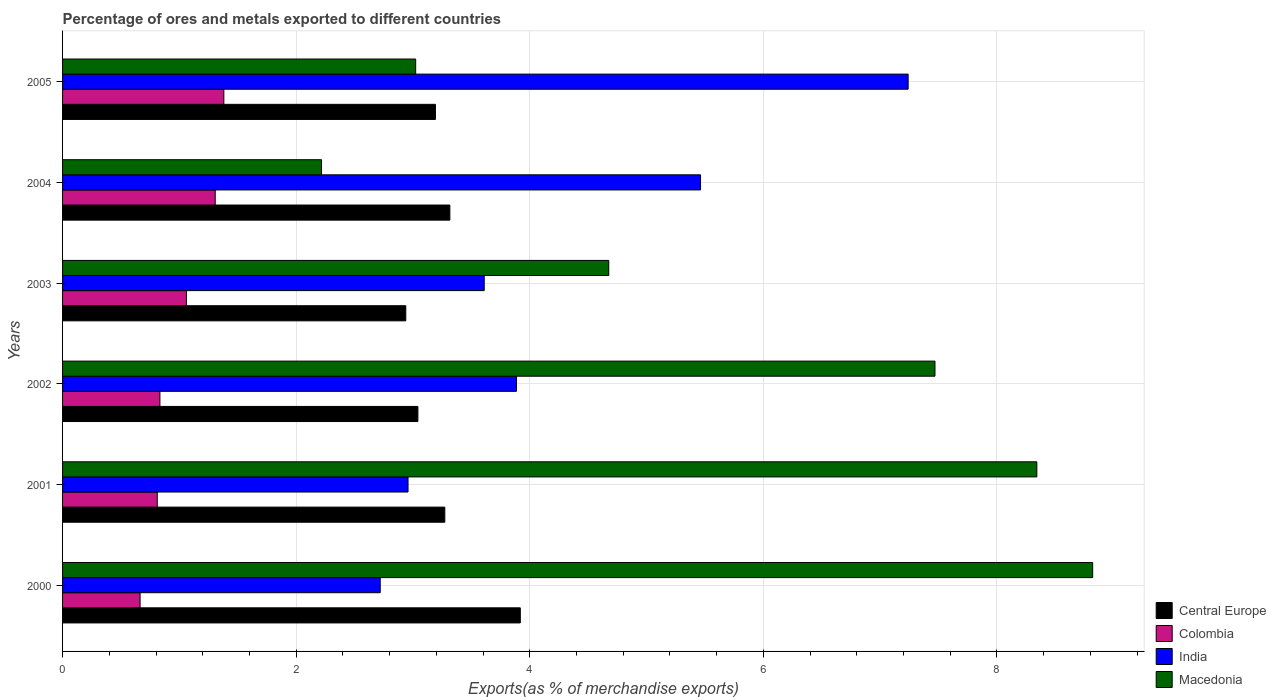How many different coloured bars are there?
Your response must be concise. 4. Are the number of bars per tick equal to the number of legend labels?
Offer a terse response. Yes. How many bars are there on the 5th tick from the top?
Ensure brevity in your answer.  4. How many bars are there on the 2nd tick from the bottom?
Your response must be concise. 4. What is the percentage of exports to different countries in Colombia in 2002?
Offer a very short reply. 0.83. Across all years, what is the maximum percentage of exports to different countries in India?
Your answer should be compact. 7.24. Across all years, what is the minimum percentage of exports to different countries in Central Europe?
Make the answer very short. 2.94. In which year was the percentage of exports to different countries in Central Europe maximum?
Your answer should be compact. 2000. What is the total percentage of exports to different countries in India in the graph?
Give a very brief answer. 25.88. What is the difference between the percentage of exports to different countries in Central Europe in 2000 and that in 2001?
Your response must be concise. 0.65. What is the difference between the percentage of exports to different countries in Colombia in 2005 and the percentage of exports to different countries in India in 2000?
Provide a succinct answer. -1.34. What is the average percentage of exports to different countries in Central Europe per year?
Your response must be concise. 3.28. In the year 2002, what is the difference between the percentage of exports to different countries in Colombia and percentage of exports to different countries in Macedonia?
Your response must be concise. -6.64. In how many years, is the percentage of exports to different countries in Colombia greater than 1.6 %?
Your answer should be very brief. 0. What is the ratio of the percentage of exports to different countries in India in 2001 to that in 2005?
Offer a very short reply. 0.41. Is the difference between the percentage of exports to different countries in Colombia in 2001 and 2003 greater than the difference between the percentage of exports to different countries in Macedonia in 2001 and 2003?
Make the answer very short. No. What is the difference between the highest and the second highest percentage of exports to different countries in Macedonia?
Keep it short and to the point. 0.48. What is the difference between the highest and the lowest percentage of exports to different countries in Colombia?
Make the answer very short. 0.72. Is the sum of the percentage of exports to different countries in Central Europe in 2003 and 2004 greater than the maximum percentage of exports to different countries in Colombia across all years?
Ensure brevity in your answer.  Yes. Is it the case that in every year, the sum of the percentage of exports to different countries in India and percentage of exports to different countries in Macedonia is greater than the sum of percentage of exports to different countries in Central Europe and percentage of exports to different countries in Colombia?
Ensure brevity in your answer.  No. What does the 1st bar from the top in 2004 represents?
Your answer should be compact. Macedonia. Is it the case that in every year, the sum of the percentage of exports to different countries in Colombia and percentage of exports to different countries in Macedonia is greater than the percentage of exports to different countries in India?
Give a very brief answer. No. How many bars are there?
Ensure brevity in your answer.  24. Are the values on the major ticks of X-axis written in scientific E-notation?
Offer a very short reply. No. Does the graph contain any zero values?
Give a very brief answer. No. How many legend labels are there?
Your answer should be compact. 4. How are the legend labels stacked?
Your answer should be compact. Vertical. What is the title of the graph?
Provide a short and direct response. Percentage of ores and metals exported to different countries. What is the label or title of the X-axis?
Provide a succinct answer. Exports(as % of merchandise exports). What is the label or title of the Y-axis?
Your answer should be compact. Years. What is the Exports(as % of merchandise exports) in Central Europe in 2000?
Your response must be concise. 3.92. What is the Exports(as % of merchandise exports) of Colombia in 2000?
Your response must be concise. 0.66. What is the Exports(as % of merchandise exports) in India in 2000?
Provide a short and direct response. 2.72. What is the Exports(as % of merchandise exports) of Macedonia in 2000?
Ensure brevity in your answer.  8.82. What is the Exports(as % of merchandise exports) in Central Europe in 2001?
Provide a short and direct response. 3.27. What is the Exports(as % of merchandise exports) in Colombia in 2001?
Offer a terse response. 0.81. What is the Exports(as % of merchandise exports) in India in 2001?
Your answer should be very brief. 2.96. What is the Exports(as % of merchandise exports) of Macedonia in 2001?
Keep it short and to the point. 8.34. What is the Exports(as % of merchandise exports) of Central Europe in 2002?
Your answer should be very brief. 3.04. What is the Exports(as % of merchandise exports) of Colombia in 2002?
Keep it short and to the point. 0.83. What is the Exports(as % of merchandise exports) in India in 2002?
Provide a succinct answer. 3.89. What is the Exports(as % of merchandise exports) of Macedonia in 2002?
Ensure brevity in your answer.  7.47. What is the Exports(as % of merchandise exports) in Central Europe in 2003?
Your answer should be compact. 2.94. What is the Exports(as % of merchandise exports) of Colombia in 2003?
Keep it short and to the point. 1.06. What is the Exports(as % of merchandise exports) of India in 2003?
Your answer should be very brief. 3.61. What is the Exports(as % of merchandise exports) in Macedonia in 2003?
Your response must be concise. 4.68. What is the Exports(as % of merchandise exports) of Central Europe in 2004?
Provide a short and direct response. 3.32. What is the Exports(as % of merchandise exports) of Colombia in 2004?
Provide a short and direct response. 1.31. What is the Exports(as % of merchandise exports) of India in 2004?
Offer a very short reply. 5.46. What is the Exports(as % of merchandise exports) in Macedonia in 2004?
Your answer should be compact. 2.22. What is the Exports(as % of merchandise exports) in Central Europe in 2005?
Give a very brief answer. 3.19. What is the Exports(as % of merchandise exports) in Colombia in 2005?
Provide a succinct answer. 1.38. What is the Exports(as % of merchandise exports) of India in 2005?
Make the answer very short. 7.24. What is the Exports(as % of merchandise exports) of Macedonia in 2005?
Keep it short and to the point. 3.02. Across all years, what is the maximum Exports(as % of merchandise exports) in Central Europe?
Offer a very short reply. 3.92. Across all years, what is the maximum Exports(as % of merchandise exports) in Colombia?
Offer a very short reply. 1.38. Across all years, what is the maximum Exports(as % of merchandise exports) of India?
Provide a succinct answer. 7.24. Across all years, what is the maximum Exports(as % of merchandise exports) in Macedonia?
Provide a short and direct response. 8.82. Across all years, what is the minimum Exports(as % of merchandise exports) of Central Europe?
Your answer should be compact. 2.94. Across all years, what is the minimum Exports(as % of merchandise exports) in Colombia?
Give a very brief answer. 0.66. Across all years, what is the minimum Exports(as % of merchandise exports) of India?
Offer a very short reply. 2.72. Across all years, what is the minimum Exports(as % of merchandise exports) in Macedonia?
Offer a very short reply. 2.22. What is the total Exports(as % of merchandise exports) of Central Europe in the graph?
Your response must be concise. 19.68. What is the total Exports(as % of merchandise exports) in Colombia in the graph?
Your response must be concise. 6.06. What is the total Exports(as % of merchandise exports) in India in the graph?
Provide a short and direct response. 25.88. What is the total Exports(as % of merchandise exports) in Macedonia in the graph?
Ensure brevity in your answer.  34.55. What is the difference between the Exports(as % of merchandise exports) of Central Europe in 2000 and that in 2001?
Keep it short and to the point. 0.65. What is the difference between the Exports(as % of merchandise exports) of Colombia in 2000 and that in 2001?
Ensure brevity in your answer.  -0.15. What is the difference between the Exports(as % of merchandise exports) of India in 2000 and that in 2001?
Provide a short and direct response. -0.24. What is the difference between the Exports(as % of merchandise exports) of Macedonia in 2000 and that in 2001?
Ensure brevity in your answer.  0.48. What is the difference between the Exports(as % of merchandise exports) of Central Europe in 2000 and that in 2002?
Provide a short and direct response. 0.88. What is the difference between the Exports(as % of merchandise exports) in Colombia in 2000 and that in 2002?
Offer a terse response. -0.17. What is the difference between the Exports(as % of merchandise exports) in India in 2000 and that in 2002?
Ensure brevity in your answer.  -1.17. What is the difference between the Exports(as % of merchandise exports) of Macedonia in 2000 and that in 2002?
Keep it short and to the point. 1.35. What is the difference between the Exports(as % of merchandise exports) of Central Europe in 2000 and that in 2003?
Make the answer very short. 0.98. What is the difference between the Exports(as % of merchandise exports) in Colombia in 2000 and that in 2003?
Provide a short and direct response. -0.4. What is the difference between the Exports(as % of merchandise exports) in India in 2000 and that in 2003?
Your answer should be very brief. -0.89. What is the difference between the Exports(as % of merchandise exports) of Macedonia in 2000 and that in 2003?
Offer a terse response. 4.14. What is the difference between the Exports(as % of merchandise exports) of Central Europe in 2000 and that in 2004?
Your response must be concise. 0.6. What is the difference between the Exports(as % of merchandise exports) of Colombia in 2000 and that in 2004?
Make the answer very short. -0.64. What is the difference between the Exports(as % of merchandise exports) of India in 2000 and that in 2004?
Keep it short and to the point. -2.74. What is the difference between the Exports(as % of merchandise exports) in Macedonia in 2000 and that in 2004?
Provide a short and direct response. 6.6. What is the difference between the Exports(as % of merchandise exports) of Central Europe in 2000 and that in 2005?
Offer a terse response. 0.73. What is the difference between the Exports(as % of merchandise exports) of Colombia in 2000 and that in 2005?
Give a very brief answer. -0.72. What is the difference between the Exports(as % of merchandise exports) in India in 2000 and that in 2005?
Make the answer very short. -4.52. What is the difference between the Exports(as % of merchandise exports) in Macedonia in 2000 and that in 2005?
Ensure brevity in your answer.  5.8. What is the difference between the Exports(as % of merchandise exports) of Central Europe in 2001 and that in 2002?
Your response must be concise. 0.23. What is the difference between the Exports(as % of merchandise exports) of Colombia in 2001 and that in 2002?
Offer a very short reply. -0.02. What is the difference between the Exports(as % of merchandise exports) of India in 2001 and that in 2002?
Give a very brief answer. -0.93. What is the difference between the Exports(as % of merchandise exports) in Macedonia in 2001 and that in 2002?
Ensure brevity in your answer.  0.87. What is the difference between the Exports(as % of merchandise exports) in Central Europe in 2001 and that in 2003?
Your response must be concise. 0.33. What is the difference between the Exports(as % of merchandise exports) in Colombia in 2001 and that in 2003?
Keep it short and to the point. -0.25. What is the difference between the Exports(as % of merchandise exports) of India in 2001 and that in 2003?
Your response must be concise. -0.65. What is the difference between the Exports(as % of merchandise exports) in Macedonia in 2001 and that in 2003?
Provide a short and direct response. 3.67. What is the difference between the Exports(as % of merchandise exports) of Central Europe in 2001 and that in 2004?
Your answer should be compact. -0.04. What is the difference between the Exports(as % of merchandise exports) of Colombia in 2001 and that in 2004?
Offer a terse response. -0.5. What is the difference between the Exports(as % of merchandise exports) of India in 2001 and that in 2004?
Offer a very short reply. -2.5. What is the difference between the Exports(as % of merchandise exports) in Macedonia in 2001 and that in 2004?
Your answer should be very brief. 6.12. What is the difference between the Exports(as % of merchandise exports) of Central Europe in 2001 and that in 2005?
Give a very brief answer. 0.08. What is the difference between the Exports(as % of merchandise exports) in Colombia in 2001 and that in 2005?
Offer a terse response. -0.57. What is the difference between the Exports(as % of merchandise exports) of India in 2001 and that in 2005?
Give a very brief answer. -4.28. What is the difference between the Exports(as % of merchandise exports) in Macedonia in 2001 and that in 2005?
Provide a short and direct response. 5.32. What is the difference between the Exports(as % of merchandise exports) of Central Europe in 2002 and that in 2003?
Offer a very short reply. 0.1. What is the difference between the Exports(as % of merchandise exports) in Colombia in 2002 and that in 2003?
Give a very brief answer. -0.23. What is the difference between the Exports(as % of merchandise exports) of India in 2002 and that in 2003?
Your response must be concise. 0.28. What is the difference between the Exports(as % of merchandise exports) of Macedonia in 2002 and that in 2003?
Your response must be concise. 2.79. What is the difference between the Exports(as % of merchandise exports) in Central Europe in 2002 and that in 2004?
Your answer should be compact. -0.27. What is the difference between the Exports(as % of merchandise exports) in Colombia in 2002 and that in 2004?
Your answer should be very brief. -0.47. What is the difference between the Exports(as % of merchandise exports) in India in 2002 and that in 2004?
Your answer should be very brief. -1.58. What is the difference between the Exports(as % of merchandise exports) in Macedonia in 2002 and that in 2004?
Your answer should be very brief. 5.25. What is the difference between the Exports(as % of merchandise exports) in Central Europe in 2002 and that in 2005?
Offer a very short reply. -0.15. What is the difference between the Exports(as % of merchandise exports) in Colombia in 2002 and that in 2005?
Your answer should be very brief. -0.55. What is the difference between the Exports(as % of merchandise exports) in India in 2002 and that in 2005?
Your response must be concise. -3.35. What is the difference between the Exports(as % of merchandise exports) of Macedonia in 2002 and that in 2005?
Keep it short and to the point. 4.45. What is the difference between the Exports(as % of merchandise exports) in Central Europe in 2003 and that in 2004?
Give a very brief answer. -0.38. What is the difference between the Exports(as % of merchandise exports) of Colombia in 2003 and that in 2004?
Provide a short and direct response. -0.25. What is the difference between the Exports(as % of merchandise exports) of India in 2003 and that in 2004?
Give a very brief answer. -1.85. What is the difference between the Exports(as % of merchandise exports) in Macedonia in 2003 and that in 2004?
Offer a very short reply. 2.46. What is the difference between the Exports(as % of merchandise exports) of Central Europe in 2003 and that in 2005?
Your response must be concise. -0.25. What is the difference between the Exports(as % of merchandise exports) in Colombia in 2003 and that in 2005?
Make the answer very short. -0.32. What is the difference between the Exports(as % of merchandise exports) in India in 2003 and that in 2005?
Provide a succinct answer. -3.63. What is the difference between the Exports(as % of merchandise exports) in Macedonia in 2003 and that in 2005?
Your answer should be compact. 1.65. What is the difference between the Exports(as % of merchandise exports) of Central Europe in 2004 and that in 2005?
Ensure brevity in your answer.  0.12. What is the difference between the Exports(as % of merchandise exports) of Colombia in 2004 and that in 2005?
Your answer should be very brief. -0.07. What is the difference between the Exports(as % of merchandise exports) in India in 2004 and that in 2005?
Offer a terse response. -1.78. What is the difference between the Exports(as % of merchandise exports) in Macedonia in 2004 and that in 2005?
Give a very brief answer. -0.81. What is the difference between the Exports(as % of merchandise exports) in Central Europe in 2000 and the Exports(as % of merchandise exports) in Colombia in 2001?
Provide a short and direct response. 3.11. What is the difference between the Exports(as % of merchandise exports) in Central Europe in 2000 and the Exports(as % of merchandise exports) in India in 2001?
Keep it short and to the point. 0.96. What is the difference between the Exports(as % of merchandise exports) of Central Europe in 2000 and the Exports(as % of merchandise exports) of Macedonia in 2001?
Provide a short and direct response. -4.42. What is the difference between the Exports(as % of merchandise exports) in Colombia in 2000 and the Exports(as % of merchandise exports) in India in 2001?
Keep it short and to the point. -2.29. What is the difference between the Exports(as % of merchandise exports) of Colombia in 2000 and the Exports(as % of merchandise exports) of Macedonia in 2001?
Ensure brevity in your answer.  -7.68. What is the difference between the Exports(as % of merchandise exports) of India in 2000 and the Exports(as % of merchandise exports) of Macedonia in 2001?
Keep it short and to the point. -5.62. What is the difference between the Exports(as % of merchandise exports) in Central Europe in 2000 and the Exports(as % of merchandise exports) in Colombia in 2002?
Your answer should be compact. 3.09. What is the difference between the Exports(as % of merchandise exports) in Central Europe in 2000 and the Exports(as % of merchandise exports) in India in 2002?
Your answer should be compact. 0.03. What is the difference between the Exports(as % of merchandise exports) of Central Europe in 2000 and the Exports(as % of merchandise exports) of Macedonia in 2002?
Ensure brevity in your answer.  -3.55. What is the difference between the Exports(as % of merchandise exports) in Colombia in 2000 and the Exports(as % of merchandise exports) in India in 2002?
Give a very brief answer. -3.22. What is the difference between the Exports(as % of merchandise exports) in Colombia in 2000 and the Exports(as % of merchandise exports) in Macedonia in 2002?
Make the answer very short. -6.81. What is the difference between the Exports(as % of merchandise exports) in India in 2000 and the Exports(as % of merchandise exports) in Macedonia in 2002?
Offer a very short reply. -4.75. What is the difference between the Exports(as % of merchandise exports) of Central Europe in 2000 and the Exports(as % of merchandise exports) of Colombia in 2003?
Offer a terse response. 2.86. What is the difference between the Exports(as % of merchandise exports) in Central Europe in 2000 and the Exports(as % of merchandise exports) in India in 2003?
Your answer should be very brief. 0.31. What is the difference between the Exports(as % of merchandise exports) in Central Europe in 2000 and the Exports(as % of merchandise exports) in Macedonia in 2003?
Ensure brevity in your answer.  -0.76. What is the difference between the Exports(as % of merchandise exports) in Colombia in 2000 and the Exports(as % of merchandise exports) in India in 2003?
Keep it short and to the point. -2.95. What is the difference between the Exports(as % of merchandise exports) of Colombia in 2000 and the Exports(as % of merchandise exports) of Macedonia in 2003?
Give a very brief answer. -4.01. What is the difference between the Exports(as % of merchandise exports) of India in 2000 and the Exports(as % of merchandise exports) of Macedonia in 2003?
Provide a short and direct response. -1.96. What is the difference between the Exports(as % of merchandise exports) in Central Europe in 2000 and the Exports(as % of merchandise exports) in Colombia in 2004?
Keep it short and to the point. 2.61. What is the difference between the Exports(as % of merchandise exports) in Central Europe in 2000 and the Exports(as % of merchandise exports) in India in 2004?
Your answer should be very brief. -1.54. What is the difference between the Exports(as % of merchandise exports) in Central Europe in 2000 and the Exports(as % of merchandise exports) in Macedonia in 2004?
Provide a short and direct response. 1.7. What is the difference between the Exports(as % of merchandise exports) of Colombia in 2000 and the Exports(as % of merchandise exports) of India in 2004?
Offer a terse response. -4.8. What is the difference between the Exports(as % of merchandise exports) in Colombia in 2000 and the Exports(as % of merchandise exports) in Macedonia in 2004?
Offer a very short reply. -1.55. What is the difference between the Exports(as % of merchandise exports) in India in 2000 and the Exports(as % of merchandise exports) in Macedonia in 2004?
Provide a succinct answer. 0.5. What is the difference between the Exports(as % of merchandise exports) in Central Europe in 2000 and the Exports(as % of merchandise exports) in Colombia in 2005?
Offer a terse response. 2.54. What is the difference between the Exports(as % of merchandise exports) in Central Europe in 2000 and the Exports(as % of merchandise exports) in India in 2005?
Offer a very short reply. -3.32. What is the difference between the Exports(as % of merchandise exports) of Central Europe in 2000 and the Exports(as % of merchandise exports) of Macedonia in 2005?
Offer a terse response. 0.9. What is the difference between the Exports(as % of merchandise exports) of Colombia in 2000 and the Exports(as % of merchandise exports) of India in 2005?
Provide a succinct answer. -6.58. What is the difference between the Exports(as % of merchandise exports) in Colombia in 2000 and the Exports(as % of merchandise exports) in Macedonia in 2005?
Make the answer very short. -2.36. What is the difference between the Exports(as % of merchandise exports) in India in 2000 and the Exports(as % of merchandise exports) in Macedonia in 2005?
Your answer should be very brief. -0.3. What is the difference between the Exports(as % of merchandise exports) of Central Europe in 2001 and the Exports(as % of merchandise exports) of Colombia in 2002?
Your answer should be very brief. 2.44. What is the difference between the Exports(as % of merchandise exports) of Central Europe in 2001 and the Exports(as % of merchandise exports) of India in 2002?
Offer a very short reply. -0.61. What is the difference between the Exports(as % of merchandise exports) in Central Europe in 2001 and the Exports(as % of merchandise exports) in Macedonia in 2002?
Provide a succinct answer. -4.2. What is the difference between the Exports(as % of merchandise exports) of Colombia in 2001 and the Exports(as % of merchandise exports) of India in 2002?
Offer a very short reply. -3.08. What is the difference between the Exports(as % of merchandise exports) of Colombia in 2001 and the Exports(as % of merchandise exports) of Macedonia in 2002?
Offer a very short reply. -6.66. What is the difference between the Exports(as % of merchandise exports) of India in 2001 and the Exports(as % of merchandise exports) of Macedonia in 2002?
Provide a short and direct response. -4.51. What is the difference between the Exports(as % of merchandise exports) of Central Europe in 2001 and the Exports(as % of merchandise exports) of Colombia in 2003?
Keep it short and to the point. 2.21. What is the difference between the Exports(as % of merchandise exports) of Central Europe in 2001 and the Exports(as % of merchandise exports) of India in 2003?
Offer a very short reply. -0.34. What is the difference between the Exports(as % of merchandise exports) in Central Europe in 2001 and the Exports(as % of merchandise exports) in Macedonia in 2003?
Ensure brevity in your answer.  -1.4. What is the difference between the Exports(as % of merchandise exports) in Colombia in 2001 and the Exports(as % of merchandise exports) in India in 2003?
Your answer should be compact. -2.8. What is the difference between the Exports(as % of merchandise exports) in Colombia in 2001 and the Exports(as % of merchandise exports) in Macedonia in 2003?
Ensure brevity in your answer.  -3.87. What is the difference between the Exports(as % of merchandise exports) of India in 2001 and the Exports(as % of merchandise exports) of Macedonia in 2003?
Your answer should be compact. -1.72. What is the difference between the Exports(as % of merchandise exports) of Central Europe in 2001 and the Exports(as % of merchandise exports) of Colombia in 2004?
Offer a terse response. 1.97. What is the difference between the Exports(as % of merchandise exports) in Central Europe in 2001 and the Exports(as % of merchandise exports) in India in 2004?
Your answer should be very brief. -2.19. What is the difference between the Exports(as % of merchandise exports) of Central Europe in 2001 and the Exports(as % of merchandise exports) of Macedonia in 2004?
Give a very brief answer. 1.06. What is the difference between the Exports(as % of merchandise exports) of Colombia in 2001 and the Exports(as % of merchandise exports) of India in 2004?
Offer a terse response. -4.65. What is the difference between the Exports(as % of merchandise exports) of Colombia in 2001 and the Exports(as % of merchandise exports) of Macedonia in 2004?
Keep it short and to the point. -1.41. What is the difference between the Exports(as % of merchandise exports) of India in 2001 and the Exports(as % of merchandise exports) of Macedonia in 2004?
Your answer should be compact. 0.74. What is the difference between the Exports(as % of merchandise exports) of Central Europe in 2001 and the Exports(as % of merchandise exports) of Colombia in 2005?
Keep it short and to the point. 1.89. What is the difference between the Exports(as % of merchandise exports) in Central Europe in 2001 and the Exports(as % of merchandise exports) in India in 2005?
Keep it short and to the point. -3.97. What is the difference between the Exports(as % of merchandise exports) of Central Europe in 2001 and the Exports(as % of merchandise exports) of Macedonia in 2005?
Give a very brief answer. 0.25. What is the difference between the Exports(as % of merchandise exports) of Colombia in 2001 and the Exports(as % of merchandise exports) of India in 2005?
Your answer should be compact. -6.43. What is the difference between the Exports(as % of merchandise exports) of Colombia in 2001 and the Exports(as % of merchandise exports) of Macedonia in 2005?
Give a very brief answer. -2.21. What is the difference between the Exports(as % of merchandise exports) of India in 2001 and the Exports(as % of merchandise exports) of Macedonia in 2005?
Your response must be concise. -0.07. What is the difference between the Exports(as % of merchandise exports) in Central Europe in 2002 and the Exports(as % of merchandise exports) in Colombia in 2003?
Your response must be concise. 1.98. What is the difference between the Exports(as % of merchandise exports) in Central Europe in 2002 and the Exports(as % of merchandise exports) in India in 2003?
Provide a short and direct response. -0.57. What is the difference between the Exports(as % of merchandise exports) in Central Europe in 2002 and the Exports(as % of merchandise exports) in Macedonia in 2003?
Your answer should be very brief. -1.63. What is the difference between the Exports(as % of merchandise exports) of Colombia in 2002 and the Exports(as % of merchandise exports) of India in 2003?
Offer a very short reply. -2.78. What is the difference between the Exports(as % of merchandise exports) in Colombia in 2002 and the Exports(as % of merchandise exports) in Macedonia in 2003?
Make the answer very short. -3.84. What is the difference between the Exports(as % of merchandise exports) in India in 2002 and the Exports(as % of merchandise exports) in Macedonia in 2003?
Your answer should be compact. -0.79. What is the difference between the Exports(as % of merchandise exports) of Central Europe in 2002 and the Exports(as % of merchandise exports) of Colombia in 2004?
Your answer should be very brief. 1.74. What is the difference between the Exports(as % of merchandise exports) in Central Europe in 2002 and the Exports(as % of merchandise exports) in India in 2004?
Your answer should be compact. -2.42. What is the difference between the Exports(as % of merchandise exports) in Central Europe in 2002 and the Exports(as % of merchandise exports) in Macedonia in 2004?
Keep it short and to the point. 0.83. What is the difference between the Exports(as % of merchandise exports) in Colombia in 2002 and the Exports(as % of merchandise exports) in India in 2004?
Provide a succinct answer. -4.63. What is the difference between the Exports(as % of merchandise exports) of Colombia in 2002 and the Exports(as % of merchandise exports) of Macedonia in 2004?
Make the answer very short. -1.38. What is the difference between the Exports(as % of merchandise exports) of India in 2002 and the Exports(as % of merchandise exports) of Macedonia in 2004?
Make the answer very short. 1.67. What is the difference between the Exports(as % of merchandise exports) in Central Europe in 2002 and the Exports(as % of merchandise exports) in Colombia in 2005?
Your answer should be very brief. 1.66. What is the difference between the Exports(as % of merchandise exports) in Central Europe in 2002 and the Exports(as % of merchandise exports) in India in 2005?
Keep it short and to the point. -4.2. What is the difference between the Exports(as % of merchandise exports) in Central Europe in 2002 and the Exports(as % of merchandise exports) in Macedonia in 2005?
Your response must be concise. 0.02. What is the difference between the Exports(as % of merchandise exports) in Colombia in 2002 and the Exports(as % of merchandise exports) in India in 2005?
Ensure brevity in your answer.  -6.41. What is the difference between the Exports(as % of merchandise exports) in Colombia in 2002 and the Exports(as % of merchandise exports) in Macedonia in 2005?
Your response must be concise. -2.19. What is the difference between the Exports(as % of merchandise exports) of India in 2002 and the Exports(as % of merchandise exports) of Macedonia in 2005?
Make the answer very short. 0.86. What is the difference between the Exports(as % of merchandise exports) of Central Europe in 2003 and the Exports(as % of merchandise exports) of Colombia in 2004?
Offer a terse response. 1.63. What is the difference between the Exports(as % of merchandise exports) of Central Europe in 2003 and the Exports(as % of merchandise exports) of India in 2004?
Give a very brief answer. -2.52. What is the difference between the Exports(as % of merchandise exports) of Central Europe in 2003 and the Exports(as % of merchandise exports) of Macedonia in 2004?
Your answer should be compact. 0.72. What is the difference between the Exports(as % of merchandise exports) of Colombia in 2003 and the Exports(as % of merchandise exports) of India in 2004?
Your response must be concise. -4.4. What is the difference between the Exports(as % of merchandise exports) in Colombia in 2003 and the Exports(as % of merchandise exports) in Macedonia in 2004?
Provide a short and direct response. -1.16. What is the difference between the Exports(as % of merchandise exports) in India in 2003 and the Exports(as % of merchandise exports) in Macedonia in 2004?
Provide a succinct answer. 1.39. What is the difference between the Exports(as % of merchandise exports) in Central Europe in 2003 and the Exports(as % of merchandise exports) in Colombia in 2005?
Your response must be concise. 1.56. What is the difference between the Exports(as % of merchandise exports) of Central Europe in 2003 and the Exports(as % of merchandise exports) of India in 2005?
Ensure brevity in your answer.  -4.3. What is the difference between the Exports(as % of merchandise exports) in Central Europe in 2003 and the Exports(as % of merchandise exports) in Macedonia in 2005?
Make the answer very short. -0.08. What is the difference between the Exports(as % of merchandise exports) of Colombia in 2003 and the Exports(as % of merchandise exports) of India in 2005?
Your answer should be very brief. -6.18. What is the difference between the Exports(as % of merchandise exports) of Colombia in 2003 and the Exports(as % of merchandise exports) of Macedonia in 2005?
Give a very brief answer. -1.96. What is the difference between the Exports(as % of merchandise exports) in India in 2003 and the Exports(as % of merchandise exports) in Macedonia in 2005?
Your answer should be very brief. 0.59. What is the difference between the Exports(as % of merchandise exports) in Central Europe in 2004 and the Exports(as % of merchandise exports) in Colombia in 2005?
Ensure brevity in your answer.  1.94. What is the difference between the Exports(as % of merchandise exports) of Central Europe in 2004 and the Exports(as % of merchandise exports) of India in 2005?
Your response must be concise. -3.92. What is the difference between the Exports(as % of merchandise exports) of Central Europe in 2004 and the Exports(as % of merchandise exports) of Macedonia in 2005?
Provide a short and direct response. 0.29. What is the difference between the Exports(as % of merchandise exports) in Colombia in 2004 and the Exports(as % of merchandise exports) in India in 2005?
Give a very brief answer. -5.93. What is the difference between the Exports(as % of merchandise exports) of Colombia in 2004 and the Exports(as % of merchandise exports) of Macedonia in 2005?
Your answer should be compact. -1.72. What is the difference between the Exports(as % of merchandise exports) of India in 2004 and the Exports(as % of merchandise exports) of Macedonia in 2005?
Keep it short and to the point. 2.44. What is the average Exports(as % of merchandise exports) in Central Europe per year?
Make the answer very short. 3.28. What is the average Exports(as % of merchandise exports) of Colombia per year?
Keep it short and to the point. 1.01. What is the average Exports(as % of merchandise exports) of India per year?
Give a very brief answer. 4.31. What is the average Exports(as % of merchandise exports) in Macedonia per year?
Offer a very short reply. 5.76. In the year 2000, what is the difference between the Exports(as % of merchandise exports) of Central Europe and Exports(as % of merchandise exports) of Colombia?
Give a very brief answer. 3.26. In the year 2000, what is the difference between the Exports(as % of merchandise exports) of Central Europe and Exports(as % of merchandise exports) of India?
Your answer should be very brief. 1.2. In the year 2000, what is the difference between the Exports(as % of merchandise exports) in Central Europe and Exports(as % of merchandise exports) in Macedonia?
Make the answer very short. -4.9. In the year 2000, what is the difference between the Exports(as % of merchandise exports) of Colombia and Exports(as % of merchandise exports) of India?
Your answer should be compact. -2.06. In the year 2000, what is the difference between the Exports(as % of merchandise exports) in Colombia and Exports(as % of merchandise exports) in Macedonia?
Provide a short and direct response. -8.16. In the year 2000, what is the difference between the Exports(as % of merchandise exports) of India and Exports(as % of merchandise exports) of Macedonia?
Give a very brief answer. -6.1. In the year 2001, what is the difference between the Exports(as % of merchandise exports) of Central Europe and Exports(as % of merchandise exports) of Colombia?
Give a very brief answer. 2.46. In the year 2001, what is the difference between the Exports(as % of merchandise exports) in Central Europe and Exports(as % of merchandise exports) in India?
Offer a very short reply. 0.32. In the year 2001, what is the difference between the Exports(as % of merchandise exports) in Central Europe and Exports(as % of merchandise exports) in Macedonia?
Your response must be concise. -5.07. In the year 2001, what is the difference between the Exports(as % of merchandise exports) of Colombia and Exports(as % of merchandise exports) of India?
Offer a terse response. -2.15. In the year 2001, what is the difference between the Exports(as % of merchandise exports) of Colombia and Exports(as % of merchandise exports) of Macedonia?
Keep it short and to the point. -7.53. In the year 2001, what is the difference between the Exports(as % of merchandise exports) of India and Exports(as % of merchandise exports) of Macedonia?
Your answer should be very brief. -5.38. In the year 2002, what is the difference between the Exports(as % of merchandise exports) of Central Europe and Exports(as % of merchandise exports) of Colombia?
Your answer should be compact. 2.21. In the year 2002, what is the difference between the Exports(as % of merchandise exports) in Central Europe and Exports(as % of merchandise exports) in India?
Give a very brief answer. -0.84. In the year 2002, what is the difference between the Exports(as % of merchandise exports) in Central Europe and Exports(as % of merchandise exports) in Macedonia?
Offer a terse response. -4.43. In the year 2002, what is the difference between the Exports(as % of merchandise exports) in Colombia and Exports(as % of merchandise exports) in India?
Your answer should be very brief. -3.05. In the year 2002, what is the difference between the Exports(as % of merchandise exports) of Colombia and Exports(as % of merchandise exports) of Macedonia?
Your answer should be very brief. -6.64. In the year 2002, what is the difference between the Exports(as % of merchandise exports) of India and Exports(as % of merchandise exports) of Macedonia?
Provide a succinct answer. -3.58. In the year 2003, what is the difference between the Exports(as % of merchandise exports) in Central Europe and Exports(as % of merchandise exports) in Colombia?
Give a very brief answer. 1.88. In the year 2003, what is the difference between the Exports(as % of merchandise exports) of Central Europe and Exports(as % of merchandise exports) of India?
Give a very brief answer. -0.67. In the year 2003, what is the difference between the Exports(as % of merchandise exports) in Central Europe and Exports(as % of merchandise exports) in Macedonia?
Your answer should be very brief. -1.74. In the year 2003, what is the difference between the Exports(as % of merchandise exports) of Colombia and Exports(as % of merchandise exports) of India?
Your answer should be very brief. -2.55. In the year 2003, what is the difference between the Exports(as % of merchandise exports) of Colombia and Exports(as % of merchandise exports) of Macedonia?
Offer a very short reply. -3.62. In the year 2003, what is the difference between the Exports(as % of merchandise exports) of India and Exports(as % of merchandise exports) of Macedonia?
Offer a very short reply. -1.07. In the year 2004, what is the difference between the Exports(as % of merchandise exports) of Central Europe and Exports(as % of merchandise exports) of Colombia?
Offer a terse response. 2.01. In the year 2004, what is the difference between the Exports(as % of merchandise exports) in Central Europe and Exports(as % of merchandise exports) in India?
Provide a succinct answer. -2.15. In the year 2004, what is the difference between the Exports(as % of merchandise exports) in Central Europe and Exports(as % of merchandise exports) in Macedonia?
Offer a very short reply. 1.1. In the year 2004, what is the difference between the Exports(as % of merchandise exports) of Colombia and Exports(as % of merchandise exports) of India?
Offer a very short reply. -4.16. In the year 2004, what is the difference between the Exports(as % of merchandise exports) in Colombia and Exports(as % of merchandise exports) in Macedonia?
Keep it short and to the point. -0.91. In the year 2004, what is the difference between the Exports(as % of merchandise exports) of India and Exports(as % of merchandise exports) of Macedonia?
Your response must be concise. 3.25. In the year 2005, what is the difference between the Exports(as % of merchandise exports) of Central Europe and Exports(as % of merchandise exports) of Colombia?
Provide a succinct answer. 1.81. In the year 2005, what is the difference between the Exports(as % of merchandise exports) in Central Europe and Exports(as % of merchandise exports) in India?
Your answer should be compact. -4.05. In the year 2005, what is the difference between the Exports(as % of merchandise exports) of Central Europe and Exports(as % of merchandise exports) of Macedonia?
Your answer should be very brief. 0.17. In the year 2005, what is the difference between the Exports(as % of merchandise exports) of Colombia and Exports(as % of merchandise exports) of India?
Offer a terse response. -5.86. In the year 2005, what is the difference between the Exports(as % of merchandise exports) of Colombia and Exports(as % of merchandise exports) of Macedonia?
Offer a terse response. -1.64. In the year 2005, what is the difference between the Exports(as % of merchandise exports) of India and Exports(as % of merchandise exports) of Macedonia?
Offer a very short reply. 4.22. What is the ratio of the Exports(as % of merchandise exports) of Central Europe in 2000 to that in 2001?
Ensure brevity in your answer.  1.2. What is the ratio of the Exports(as % of merchandise exports) of Colombia in 2000 to that in 2001?
Keep it short and to the point. 0.82. What is the ratio of the Exports(as % of merchandise exports) of India in 2000 to that in 2001?
Your answer should be compact. 0.92. What is the ratio of the Exports(as % of merchandise exports) in Macedonia in 2000 to that in 2001?
Keep it short and to the point. 1.06. What is the ratio of the Exports(as % of merchandise exports) in Central Europe in 2000 to that in 2002?
Keep it short and to the point. 1.29. What is the ratio of the Exports(as % of merchandise exports) in Colombia in 2000 to that in 2002?
Provide a succinct answer. 0.8. What is the ratio of the Exports(as % of merchandise exports) in India in 2000 to that in 2002?
Offer a very short reply. 0.7. What is the ratio of the Exports(as % of merchandise exports) of Macedonia in 2000 to that in 2002?
Your answer should be very brief. 1.18. What is the ratio of the Exports(as % of merchandise exports) in Central Europe in 2000 to that in 2003?
Your answer should be compact. 1.33. What is the ratio of the Exports(as % of merchandise exports) in Colombia in 2000 to that in 2003?
Keep it short and to the point. 0.63. What is the ratio of the Exports(as % of merchandise exports) of India in 2000 to that in 2003?
Your response must be concise. 0.75. What is the ratio of the Exports(as % of merchandise exports) in Macedonia in 2000 to that in 2003?
Offer a very short reply. 1.89. What is the ratio of the Exports(as % of merchandise exports) of Central Europe in 2000 to that in 2004?
Your answer should be very brief. 1.18. What is the ratio of the Exports(as % of merchandise exports) of Colombia in 2000 to that in 2004?
Ensure brevity in your answer.  0.51. What is the ratio of the Exports(as % of merchandise exports) of India in 2000 to that in 2004?
Provide a succinct answer. 0.5. What is the ratio of the Exports(as % of merchandise exports) in Macedonia in 2000 to that in 2004?
Ensure brevity in your answer.  3.98. What is the ratio of the Exports(as % of merchandise exports) of Central Europe in 2000 to that in 2005?
Make the answer very short. 1.23. What is the ratio of the Exports(as % of merchandise exports) in Colombia in 2000 to that in 2005?
Your answer should be compact. 0.48. What is the ratio of the Exports(as % of merchandise exports) of India in 2000 to that in 2005?
Provide a short and direct response. 0.38. What is the ratio of the Exports(as % of merchandise exports) of Macedonia in 2000 to that in 2005?
Your response must be concise. 2.92. What is the ratio of the Exports(as % of merchandise exports) of Central Europe in 2001 to that in 2002?
Give a very brief answer. 1.08. What is the ratio of the Exports(as % of merchandise exports) of Colombia in 2001 to that in 2002?
Offer a very short reply. 0.97. What is the ratio of the Exports(as % of merchandise exports) in India in 2001 to that in 2002?
Offer a very short reply. 0.76. What is the ratio of the Exports(as % of merchandise exports) of Macedonia in 2001 to that in 2002?
Give a very brief answer. 1.12. What is the ratio of the Exports(as % of merchandise exports) of Central Europe in 2001 to that in 2003?
Offer a very short reply. 1.11. What is the ratio of the Exports(as % of merchandise exports) in Colombia in 2001 to that in 2003?
Your response must be concise. 0.76. What is the ratio of the Exports(as % of merchandise exports) in India in 2001 to that in 2003?
Give a very brief answer. 0.82. What is the ratio of the Exports(as % of merchandise exports) in Macedonia in 2001 to that in 2003?
Your answer should be very brief. 1.78. What is the ratio of the Exports(as % of merchandise exports) of Colombia in 2001 to that in 2004?
Your answer should be very brief. 0.62. What is the ratio of the Exports(as % of merchandise exports) of India in 2001 to that in 2004?
Your answer should be very brief. 0.54. What is the ratio of the Exports(as % of merchandise exports) in Macedonia in 2001 to that in 2004?
Provide a succinct answer. 3.76. What is the ratio of the Exports(as % of merchandise exports) of Central Europe in 2001 to that in 2005?
Give a very brief answer. 1.03. What is the ratio of the Exports(as % of merchandise exports) of Colombia in 2001 to that in 2005?
Give a very brief answer. 0.59. What is the ratio of the Exports(as % of merchandise exports) in India in 2001 to that in 2005?
Offer a terse response. 0.41. What is the ratio of the Exports(as % of merchandise exports) of Macedonia in 2001 to that in 2005?
Give a very brief answer. 2.76. What is the ratio of the Exports(as % of merchandise exports) in Central Europe in 2002 to that in 2003?
Ensure brevity in your answer.  1.04. What is the ratio of the Exports(as % of merchandise exports) of Colombia in 2002 to that in 2003?
Your answer should be compact. 0.79. What is the ratio of the Exports(as % of merchandise exports) of India in 2002 to that in 2003?
Offer a terse response. 1.08. What is the ratio of the Exports(as % of merchandise exports) in Macedonia in 2002 to that in 2003?
Make the answer very short. 1.6. What is the ratio of the Exports(as % of merchandise exports) of Central Europe in 2002 to that in 2004?
Make the answer very short. 0.92. What is the ratio of the Exports(as % of merchandise exports) in Colombia in 2002 to that in 2004?
Offer a terse response. 0.64. What is the ratio of the Exports(as % of merchandise exports) in India in 2002 to that in 2004?
Give a very brief answer. 0.71. What is the ratio of the Exports(as % of merchandise exports) of Macedonia in 2002 to that in 2004?
Keep it short and to the point. 3.37. What is the ratio of the Exports(as % of merchandise exports) of Central Europe in 2002 to that in 2005?
Provide a succinct answer. 0.95. What is the ratio of the Exports(as % of merchandise exports) of Colombia in 2002 to that in 2005?
Your response must be concise. 0.6. What is the ratio of the Exports(as % of merchandise exports) in India in 2002 to that in 2005?
Provide a short and direct response. 0.54. What is the ratio of the Exports(as % of merchandise exports) in Macedonia in 2002 to that in 2005?
Your answer should be compact. 2.47. What is the ratio of the Exports(as % of merchandise exports) in Central Europe in 2003 to that in 2004?
Provide a short and direct response. 0.89. What is the ratio of the Exports(as % of merchandise exports) of Colombia in 2003 to that in 2004?
Ensure brevity in your answer.  0.81. What is the ratio of the Exports(as % of merchandise exports) in India in 2003 to that in 2004?
Make the answer very short. 0.66. What is the ratio of the Exports(as % of merchandise exports) in Macedonia in 2003 to that in 2004?
Your answer should be very brief. 2.11. What is the ratio of the Exports(as % of merchandise exports) in Central Europe in 2003 to that in 2005?
Your response must be concise. 0.92. What is the ratio of the Exports(as % of merchandise exports) in Colombia in 2003 to that in 2005?
Offer a very short reply. 0.77. What is the ratio of the Exports(as % of merchandise exports) in India in 2003 to that in 2005?
Ensure brevity in your answer.  0.5. What is the ratio of the Exports(as % of merchandise exports) in Macedonia in 2003 to that in 2005?
Give a very brief answer. 1.55. What is the ratio of the Exports(as % of merchandise exports) in Central Europe in 2004 to that in 2005?
Ensure brevity in your answer.  1.04. What is the ratio of the Exports(as % of merchandise exports) in Colombia in 2004 to that in 2005?
Ensure brevity in your answer.  0.95. What is the ratio of the Exports(as % of merchandise exports) in India in 2004 to that in 2005?
Your answer should be compact. 0.75. What is the ratio of the Exports(as % of merchandise exports) of Macedonia in 2004 to that in 2005?
Offer a very short reply. 0.73. What is the difference between the highest and the second highest Exports(as % of merchandise exports) in Central Europe?
Your answer should be very brief. 0.6. What is the difference between the highest and the second highest Exports(as % of merchandise exports) in Colombia?
Your response must be concise. 0.07. What is the difference between the highest and the second highest Exports(as % of merchandise exports) of India?
Make the answer very short. 1.78. What is the difference between the highest and the second highest Exports(as % of merchandise exports) in Macedonia?
Offer a very short reply. 0.48. What is the difference between the highest and the lowest Exports(as % of merchandise exports) of Central Europe?
Give a very brief answer. 0.98. What is the difference between the highest and the lowest Exports(as % of merchandise exports) in Colombia?
Offer a very short reply. 0.72. What is the difference between the highest and the lowest Exports(as % of merchandise exports) in India?
Provide a short and direct response. 4.52. What is the difference between the highest and the lowest Exports(as % of merchandise exports) of Macedonia?
Offer a very short reply. 6.6. 